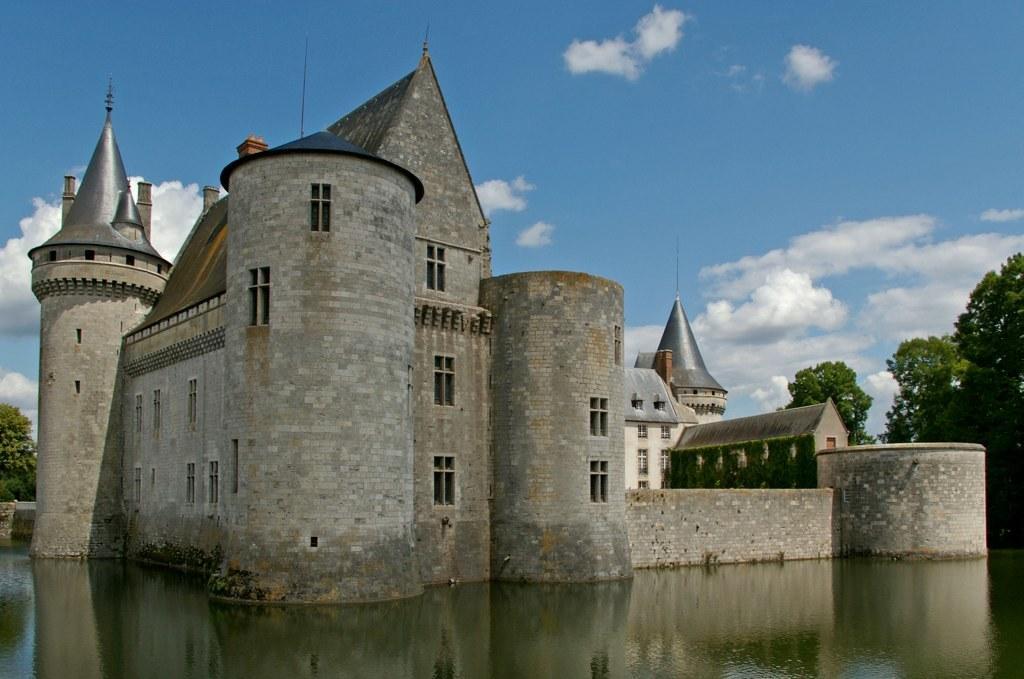Please provide a concise description of this image. This image consists of a building. At the bottom, there is water. On the right, there is a tree. At the top, there are clouds in the sky. 